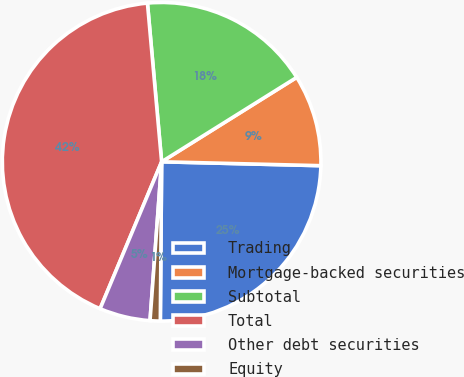<chart> <loc_0><loc_0><loc_500><loc_500><pie_chart><fcel>Trading<fcel>Mortgage-backed securities<fcel>Subtotal<fcel>Total<fcel>Other debt securities<fcel>Equity<nl><fcel>24.74%<fcel>9.28%<fcel>17.53%<fcel>42.27%<fcel>5.15%<fcel>1.03%<nl></chart> 